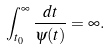Convert formula to latex. <formula><loc_0><loc_0><loc_500><loc_500>\int _ { t _ { 0 } } ^ { \infty } \frac { d t } { \psi ( t ) } = \infty .</formula> 